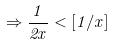Convert formula to latex. <formula><loc_0><loc_0><loc_500><loc_500>\Rightarrow \frac { 1 } { 2 x } < [ 1 / x ]</formula> 